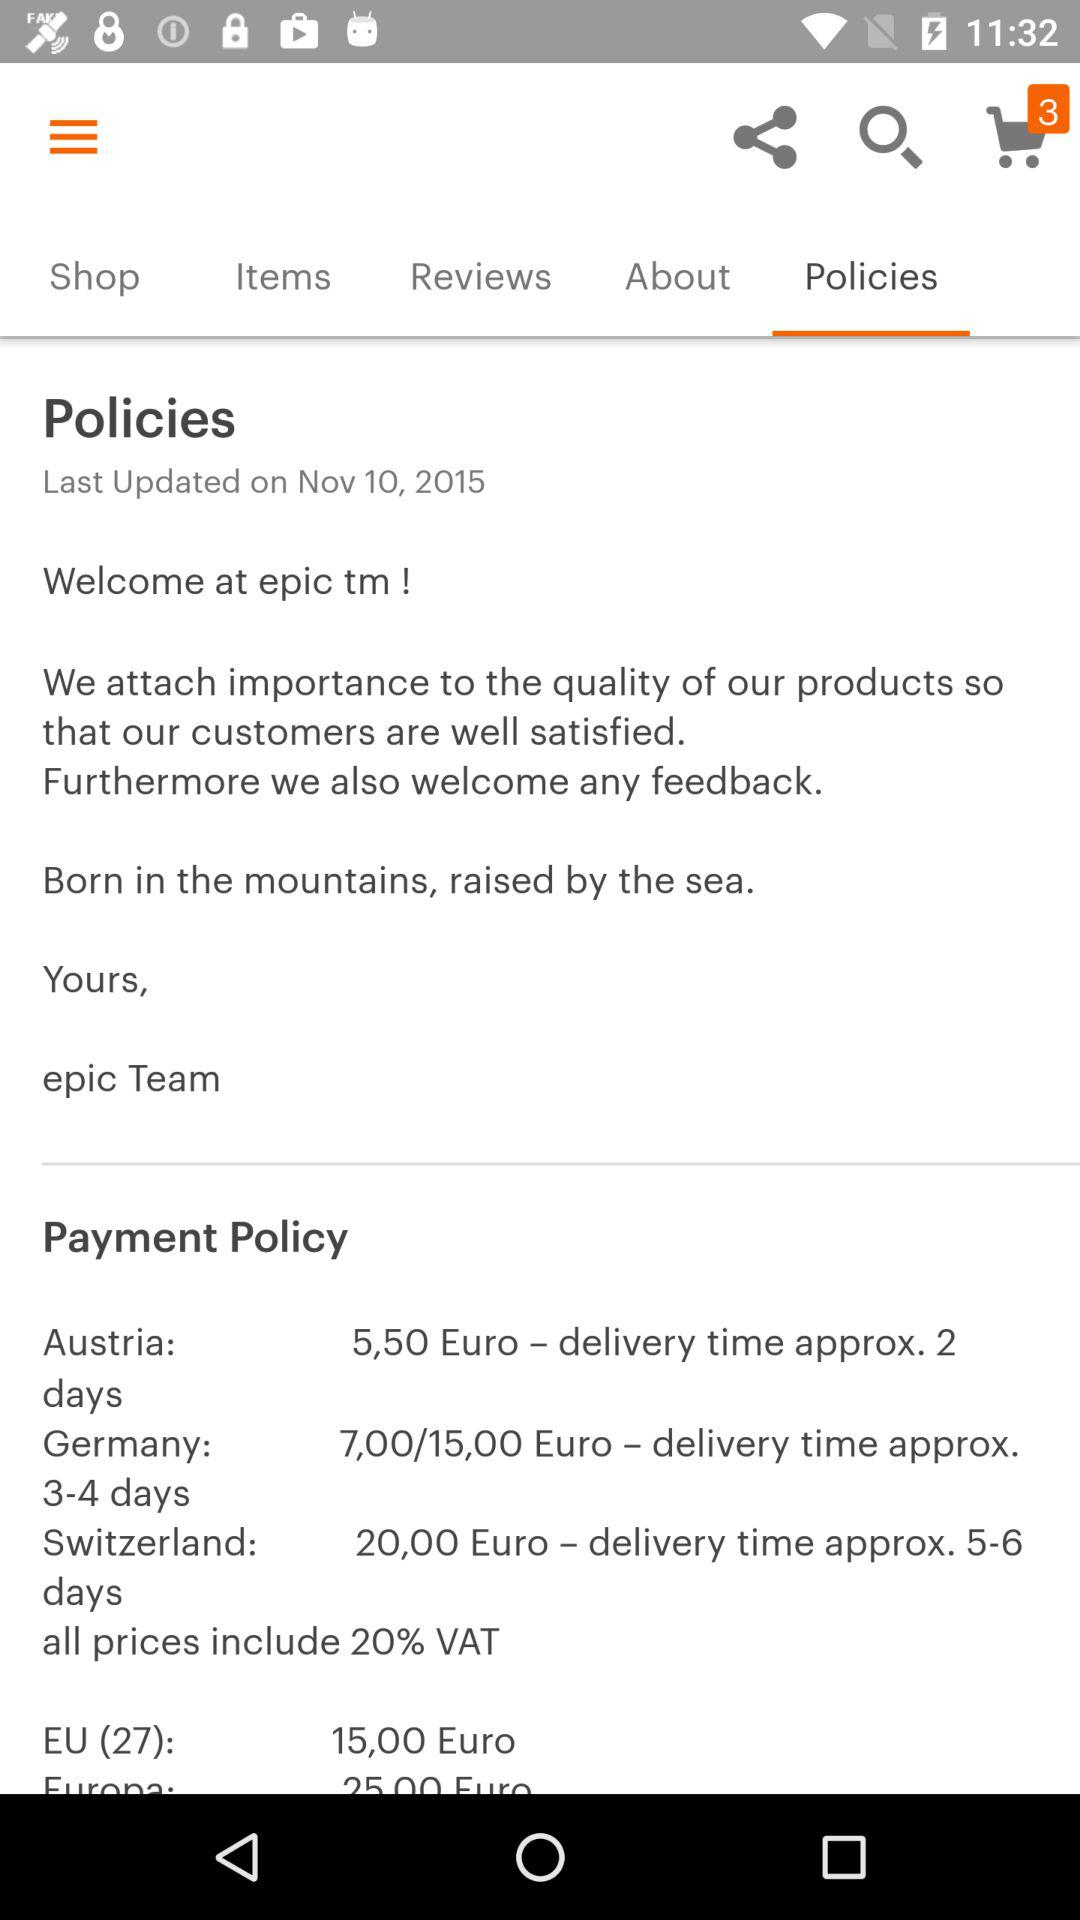What are the payment policy days for Austria?
When the provided information is insufficient, respond with <no answer>. <no answer> 